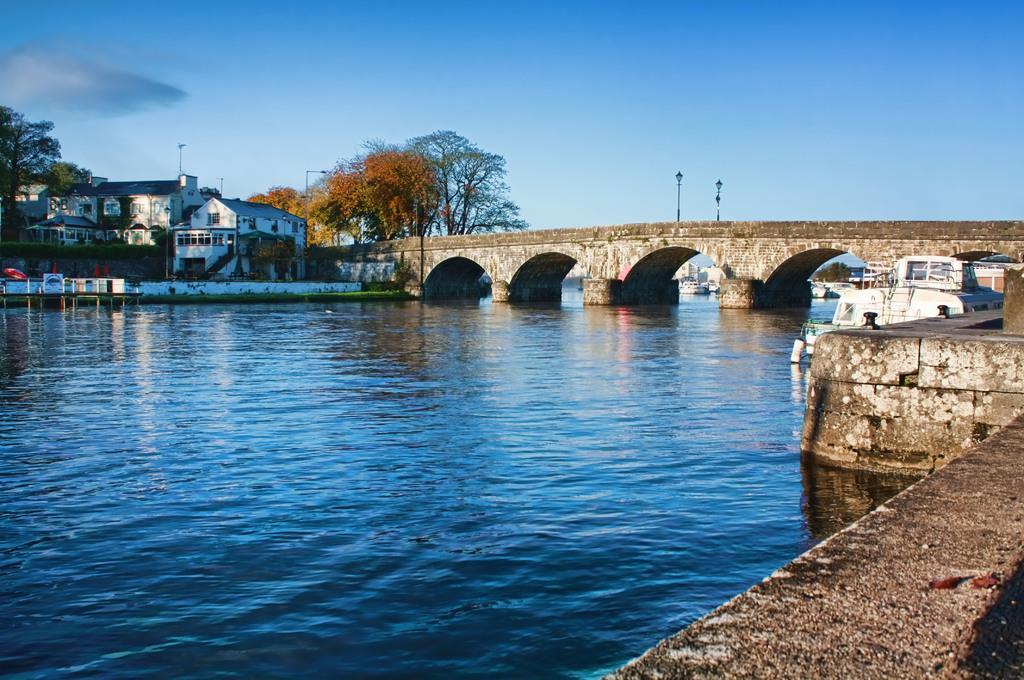Please provide a concise description of this image. In this image we can see the bridge. We can also see a boat on the water. On the backside we can see a house with a roof and windows, a fence, the trees and the sky which looks cloudy. 